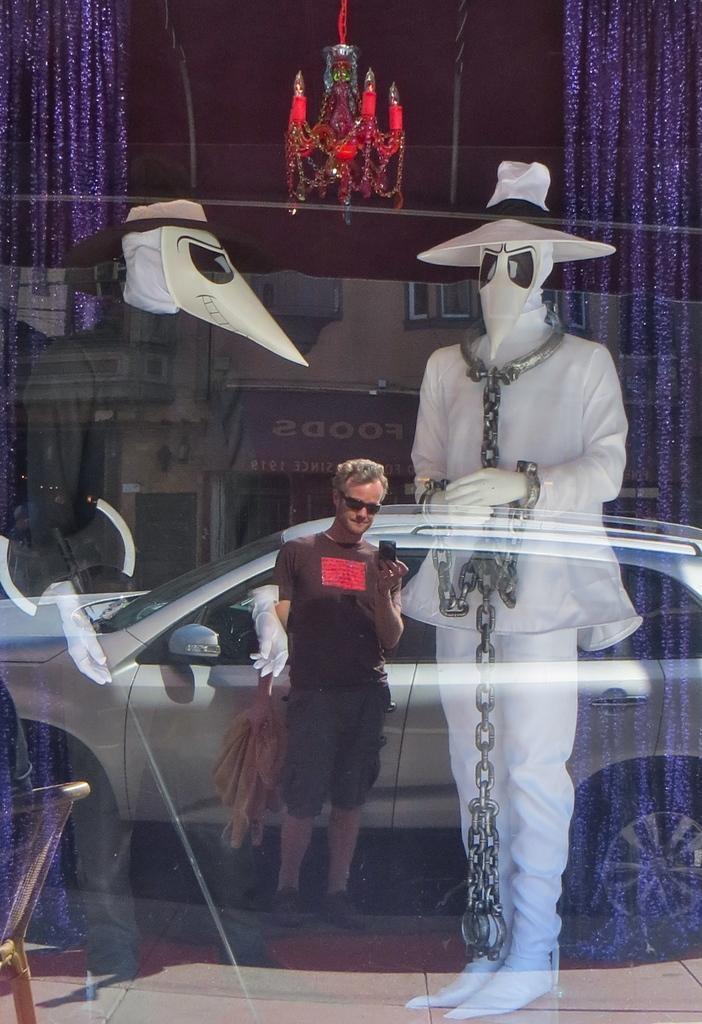Can you describe this image briefly? In this picture I can see couple of mannequins in the store and I can see reflection of a man, car and a building on the glass. 